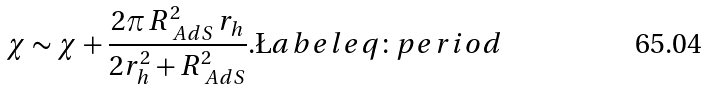<formula> <loc_0><loc_0><loc_500><loc_500>\chi \sim \chi + \frac { 2 \pi \, R _ { \ A d S } ^ { 2 } \, r _ { h } } { 2 r _ { h } ^ { 2 } + R _ { \ A d S } ^ { 2 } } . \L a b e l { e q \colon p e r i o d }</formula> 